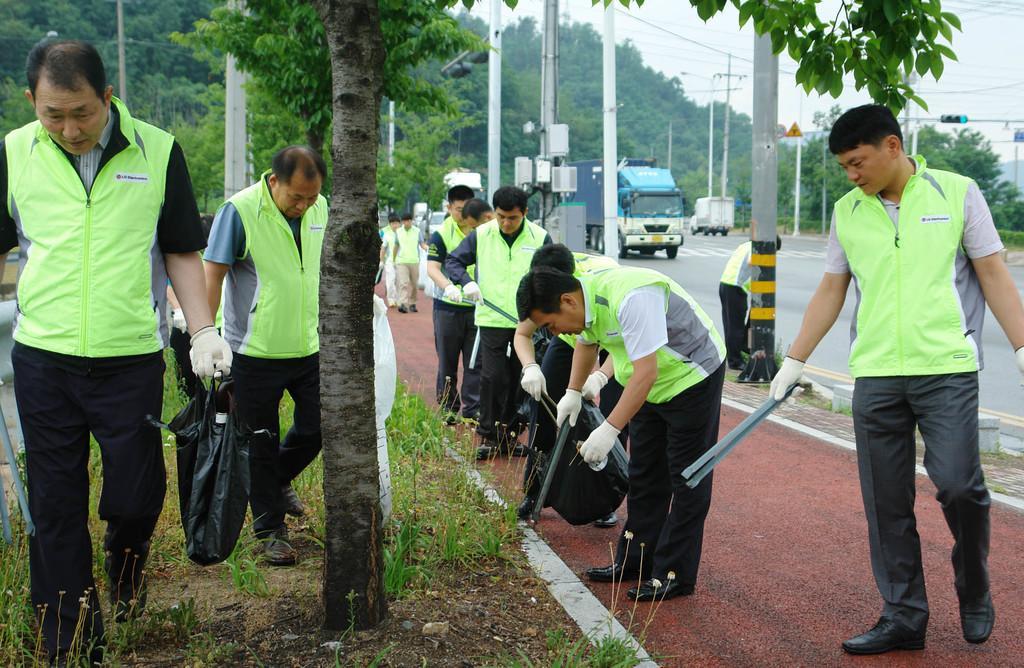Please provide a concise description of this image. Here in this picture we can see a group of men wearing aprons and gloves are cleaning the place, as they are holding plastic covers and tongs in their hands and we can also see grass, plants and trees on the ground and in the far we can see trucks present on the road and we can also see electric poles and light posts present and we can see the sky is cloudy. 